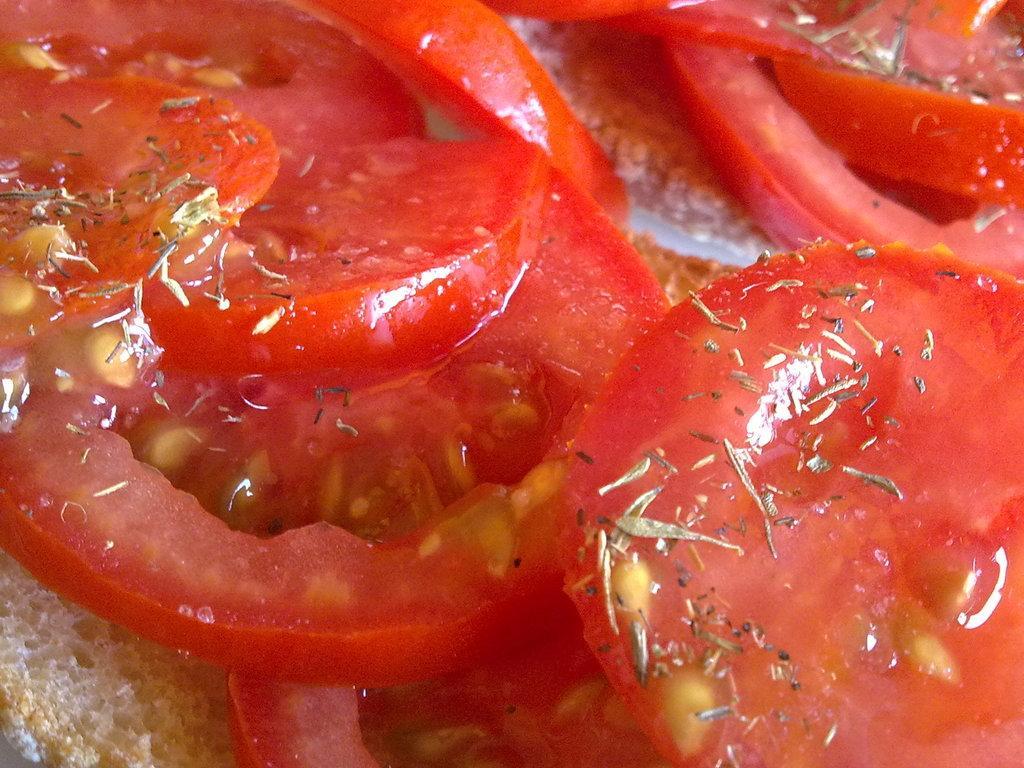In one or two sentences, can you explain what this image depicts? In this image we can see some food. 